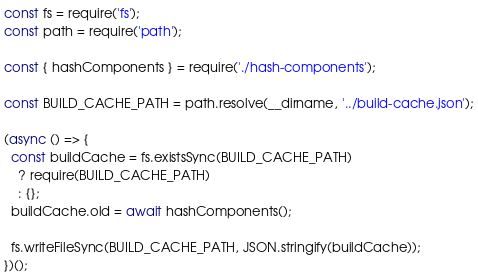Convert code to text. <code><loc_0><loc_0><loc_500><loc_500><_JavaScript_>const fs = require('fs');
const path = require('path');

const { hashComponents } = require('./hash-components');

const BUILD_CACHE_PATH = path.resolve(__dirname, '../build-cache.json');

(async () => {
  const buildCache = fs.existsSync(BUILD_CACHE_PATH)
    ? require(BUILD_CACHE_PATH)
    : {};
  buildCache.old = await hashComponents();

  fs.writeFileSync(BUILD_CACHE_PATH, JSON.stringify(buildCache));
})();
</code> 